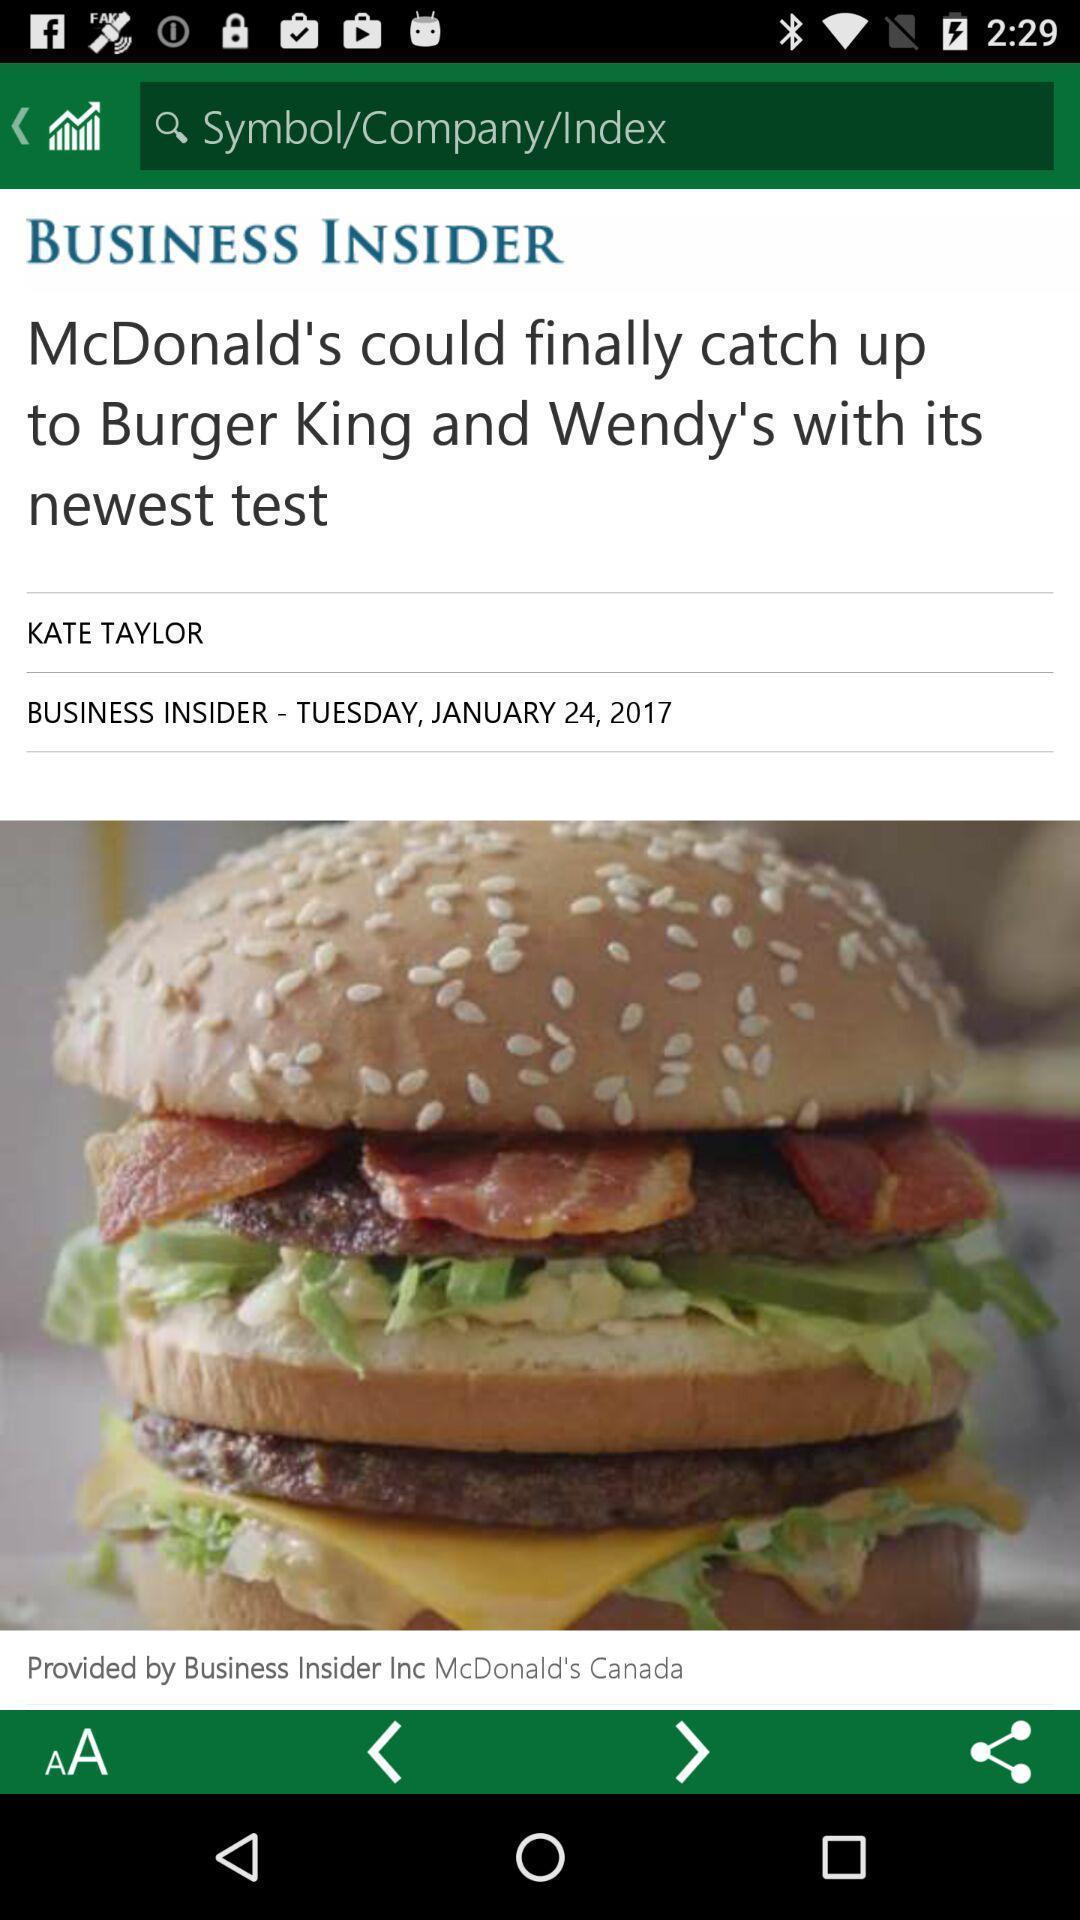Summarize the main components in this picture. Page that displaying news application. 